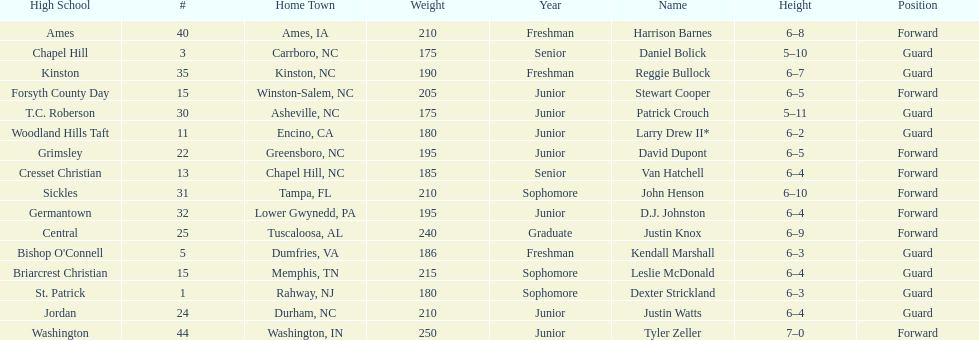How many players were taller than van hatchell? 7. 